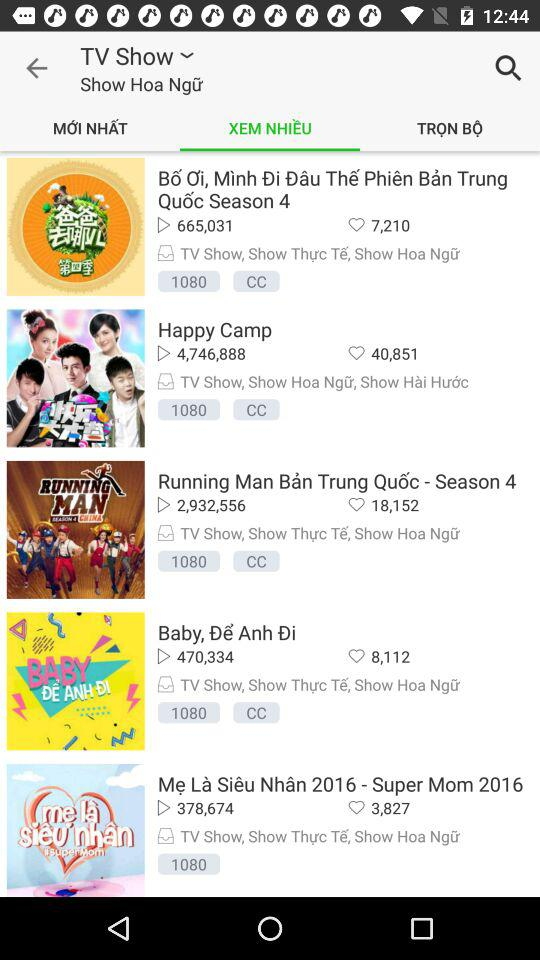How many shows are there that are in the Show Hoa Ngữ category?
Answer the question using a single word or phrase. 5 